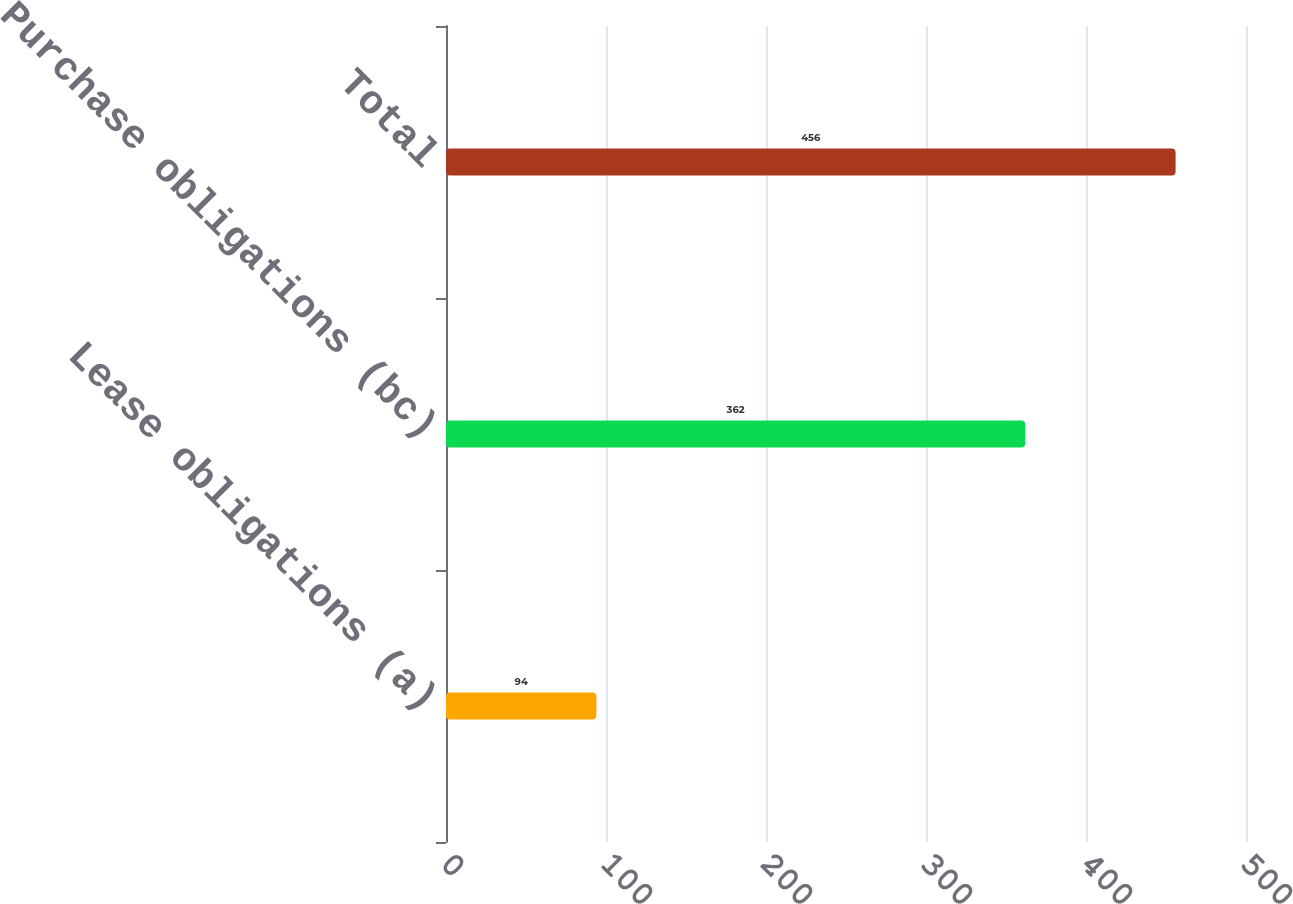Convert chart to OTSL. <chart><loc_0><loc_0><loc_500><loc_500><bar_chart><fcel>Lease obligations (a)<fcel>Purchase obligations (bc)<fcel>Total<nl><fcel>94<fcel>362<fcel>456<nl></chart> 